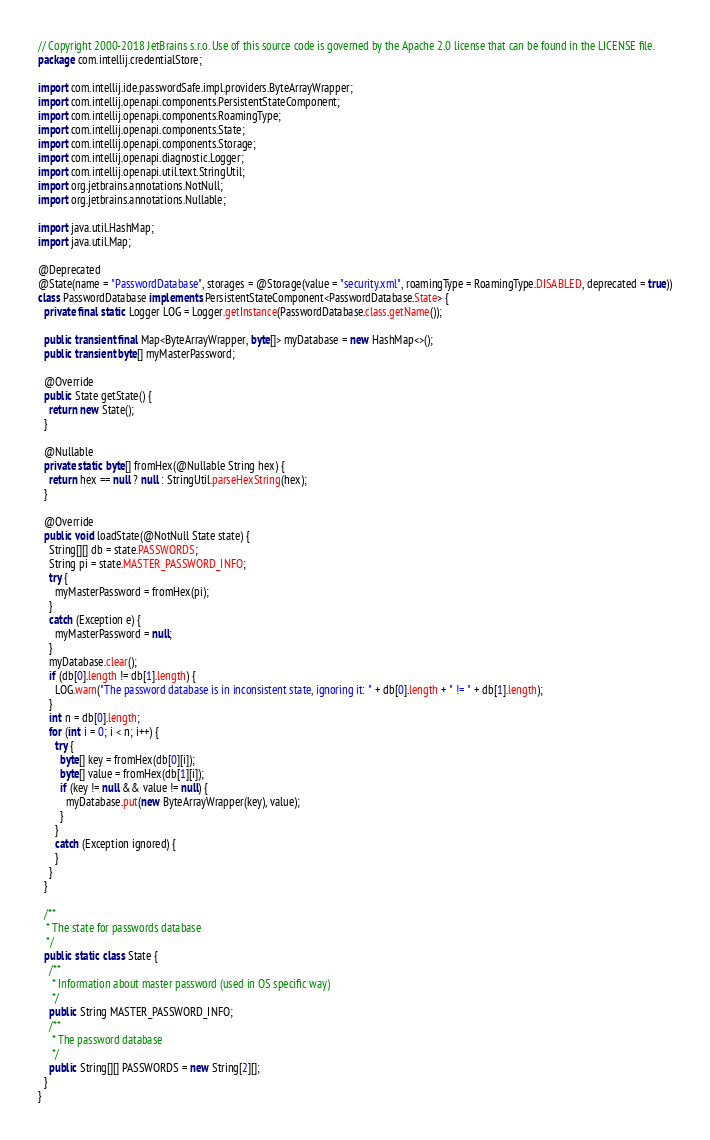Convert code to text. <code><loc_0><loc_0><loc_500><loc_500><_Java_>// Copyright 2000-2018 JetBrains s.r.o. Use of this source code is governed by the Apache 2.0 license that can be found in the LICENSE file.
package com.intellij.credentialStore;

import com.intellij.ide.passwordSafe.impl.providers.ByteArrayWrapper;
import com.intellij.openapi.components.PersistentStateComponent;
import com.intellij.openapi.components.RoamingType;
import com.intellij.openapi.components.State;
import com.intellij.openapi.components.Storage;
import com.intellij.openapi.diagnostic.Logger;
import com.intellij.openapi.util.text.StringUtil;
import org.jetbrains.annotations.NotNull;
import org.jetbrains.annotations.Nullable;

import java.util.HashMap;
import java.util.Map;

@Deprecated
@State(name = "PasswordDatabase", storages = @Storage(value = "security.xml", roamingType = RoamingType.DISABLED, deprecated = true))
class PasswordDatabase implements PersistentStateComponent<PasswordDatabase.State> {
  private final static Logger LOG = Logger.getInstance(PasswordDatabase.class.getName());

  public transient final Map<ByteArrayWrapper, byte[]> myDatabase = new HashMap<>();
  public transient byte[] myMasterPassword;

  @Override
  public State getState() {
    return new State();
  }

  @Nullable
  private static byte[] fromHex(@Nullable String hex) {
    return hex == null ? null : StringUtil.parseHexString(hex);
  }

  @Override
  public void loadState(@NotNull State state) {
    String[][] db = state.PASSWORDS;
    String pi = state.MASTER_PASSWORD_INFO;
    try {
      myMasterPassword = fromHex(pi);
    }
    catch (Exception e) {
      myMasterPassword = null;
    }
    myDatabase.clear();
    if (db[0].length != db[1].length) {
      LOG.warn("The password database is in inconsistent state, ignoring it: " + db[0].length + " != " + db[1].length);
    }
    int n = db[0].length;
    for (int i = 0; i < n; i++) {
      try {
        byte[] key = fromHex(db[0][i]);
        byte[] value = fromHex(db[1][i]);
        if (key != null && value != null) {
          myDatabase.put(new ByteArrayWrapper(key), value);
        }
      }
      catch (Exception ignored) {
      }
    }
  }

  /**
   * The state for passwords database
   */
  public static class State {
    /**
     * Information about master password (used in OS specific way)
     */
    public String MASTER_PASSWORD_INFO;
    /**
     * The password database
     */
    public String[][] PASSWORDS = new String[2][];
  }
}
</code> 